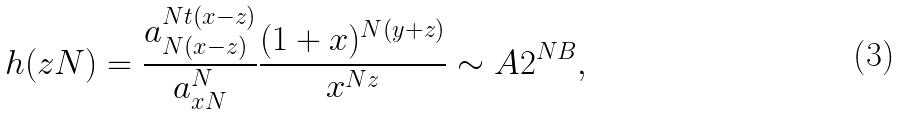<formula> <loc_0><loc_0><loc_500><loc_500>h ( z N ) = \frac { a _ { N ( x - z ) } ^ { N t ( x - z ) } } { a _ { x N } ^ { N } } \frac { ( 1 + x ) ^ { N ( y + z ) } } { x ^ { N z } } \sim A 2 ^ { N B } ,</formula> 